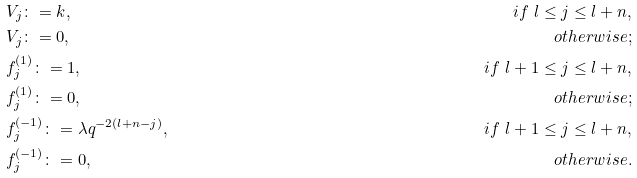Convert formula to latex. <formula><loc_0><loc_0><loc_500><loc_500>& V _ { j } \colon = k , & i f \ l \leq j \leq l + n , \\ & V _ { j } \colon = 0 , & o t h e r w i s e ; \\ & f _ { j } ^ { ( 1 ) } \colon = 1 , & i f \ l + 1 \leq j \leq l + n , \\ & f _ { j } ^ { ( 1 ) } \colon = 0 , & o t h e r w i s e ; \\ & f _ { j } ^ { ( - 1 ) } \colon = \lambda q ^ { - 2 ( l + n - j ) } , & i f \ l + 1 \leq j \leq l + n , \\ & f _ { j } ^ { ( - 1 ) } \colon = 0 , & o t h e r w i s e .</formula> 